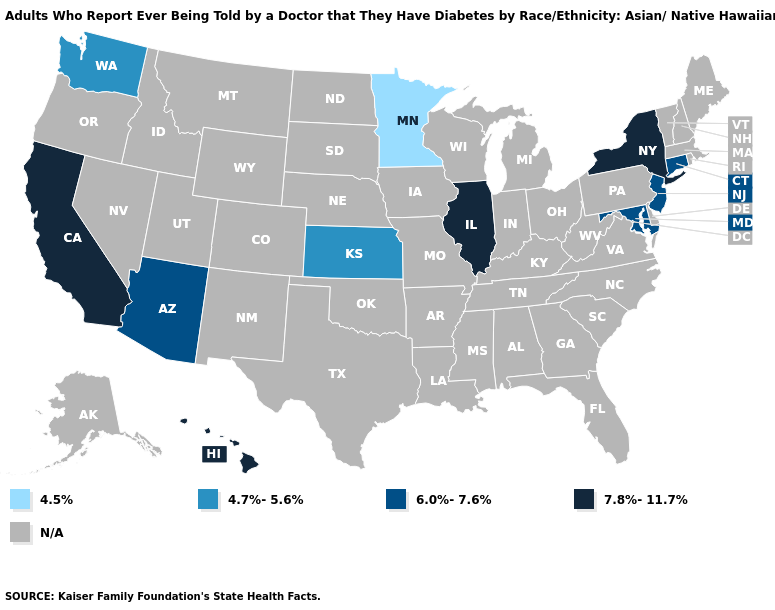Among the states that border Oregon , does California have the highest value?
Give a very brief answer. Yes. What is the value of Vermont?
Quick response, please. N/A. Does New Jersey have the highest value in the Northeast?
Answer briefly. No. Name the states that have a value in the range 4.7%-5.6%?
Give a very brief answer. Kansas, Washington. What is the value of Florida?
Short answer required. N/A. Which states have the lowest value in the USA?
Quick response, please. Minnesota. Among the states that border Oregon , does Washington have the highest value?
Answer briefly. No. What is the value of Maryland?
Answer briefly. 6.0%-7.6%. What is the value of Rhode Island?
Answer briefly. N/A. Name the states that have a value in the range 7.8%-11.7%?
Keep it brief. California, Hawaii, Illinois, New York. What is the value of New Hampshire?
Keep it brief. N/A. Does New Jersey have the highest value in the Northeast?
Answer briefly. No. Name the states that have a value in the range 6.0%-7.6%?
Short answer required. Arizona, Connecticut, Maryland, New Jersey. 